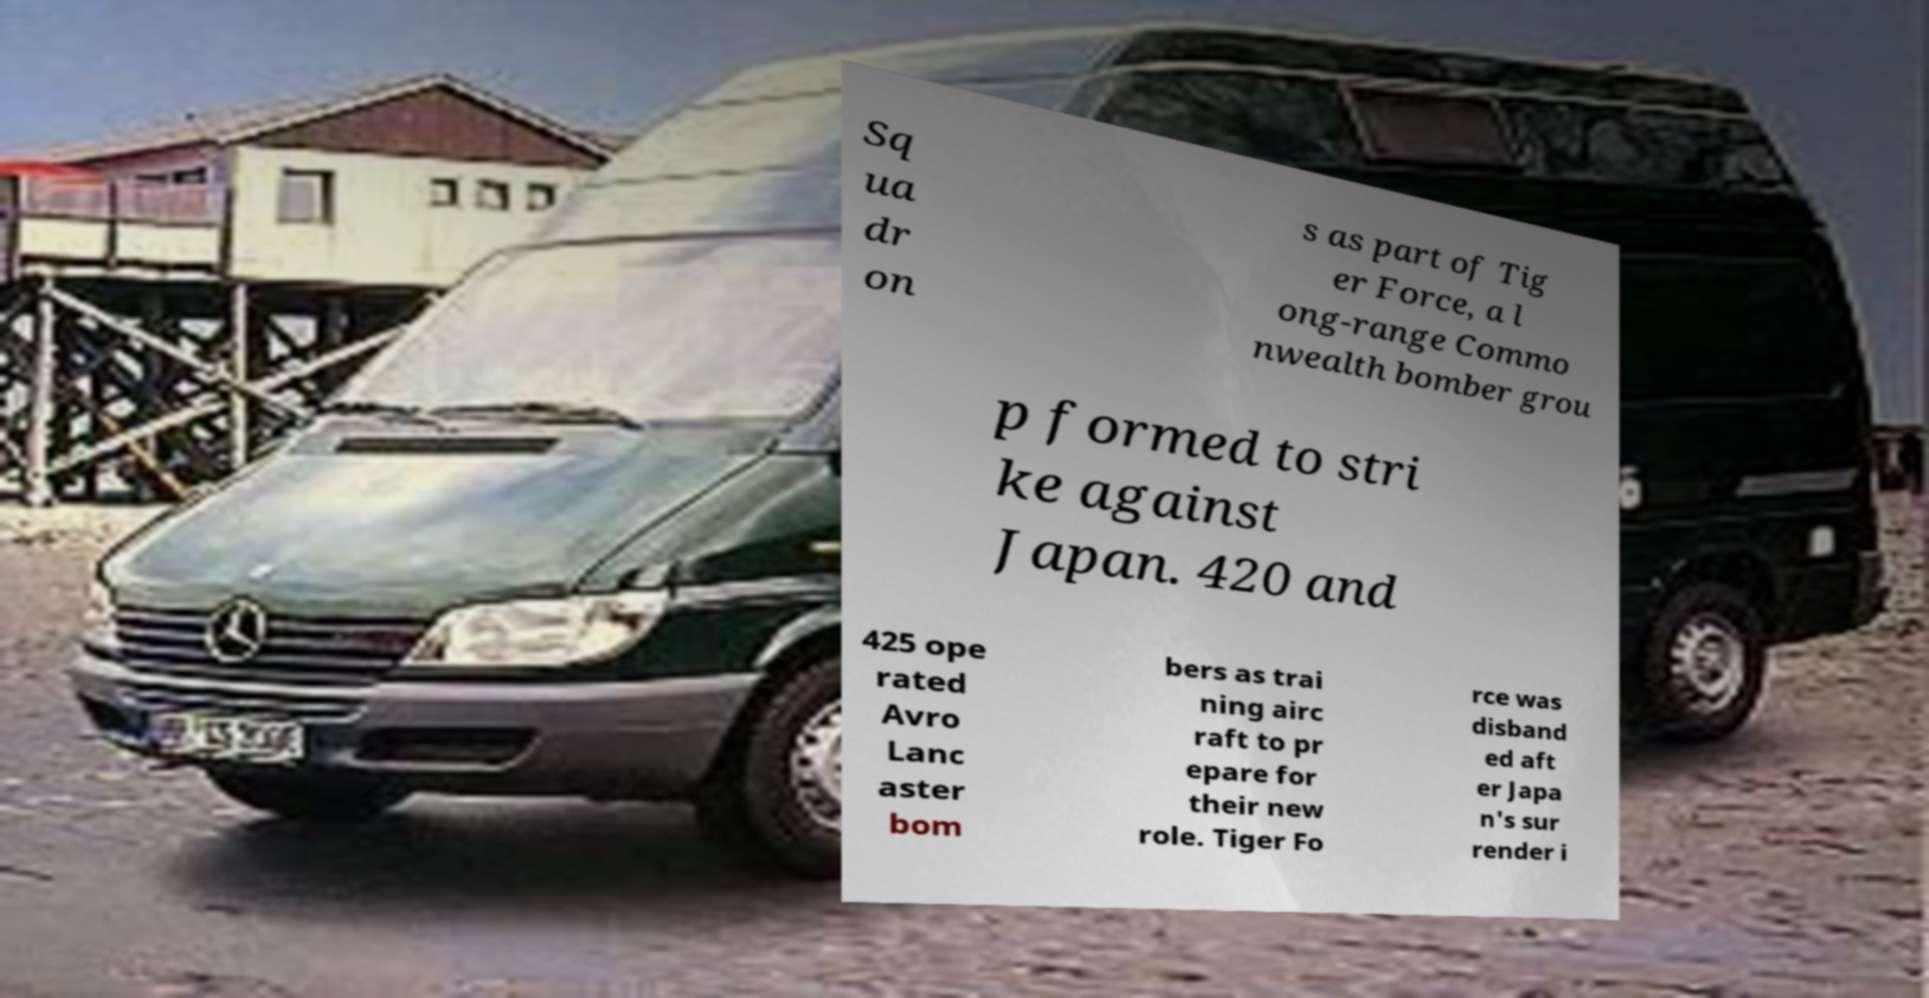There's text embedded in this image that I need extracted. Can you transcribe it verbatim? Sq ua dr on s as part of Tig er Force, a l ong-range Commo nwealth bomber grou p formed to stri ke against Japan. 420 and 425 ope rated Avro Lanc aster bom bers as trai ning airc raft to pr epare for their new role. Tiger Fo rce was disband ed aft er Japa n's sur render i 